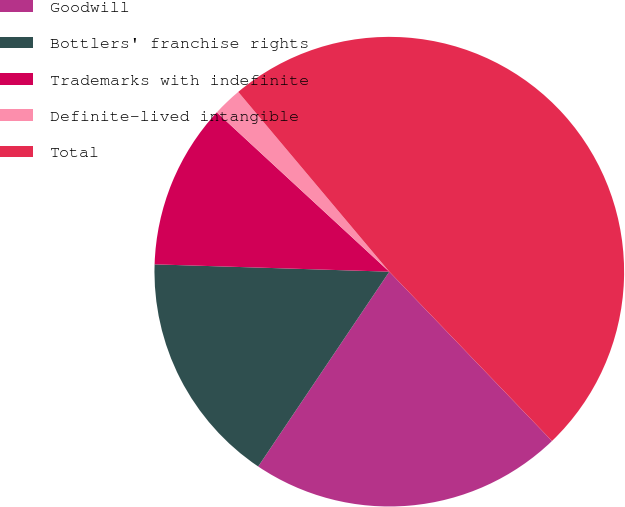Convert chart. <chart><loc_0><loc_0><loc_500><loc_500><pie_chart><fcel>Goodwill<fcel>Bottlers' franchise rights<fcel>Trademarks with indefinite<fcel>Definite-lived intangible<fcel>Total<nl><fcel>21.61%<fcel>16.07%<fcel>11.37%<fcel>2.01%<fcel>48.94%<nl></chart> 